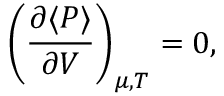<formula> <loc_0><loc_0><loc_500><loc_500>\left ( { \frac { \partial \langle P \rangle } { \partial V } } \right ) _ { \mu , T } = 0 ,</formula> 